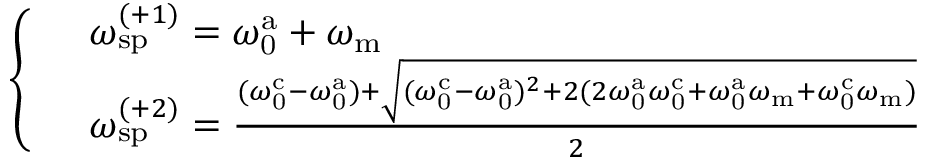Convert formula to latex. <formula><loc_0><loc_0><loc_500><loc_500>\begin{array} { r l } & { \left \{ \begin{array} { l l } & { \omega _ { s p } ^ { ( + 1 ) } = \omega _ { 0 } ^ { a } + \omega _ { m } } \\ & { \omega _ { s p } ^ { ( + 2 ) } = \frac { ( \omega _ { 0 } ^ { c } - \omega _ { 0 } ^ { a } ) + \sqrt { ( \omega _ { 0 } ^ { c } - \omega _ { 0 } ^ { a } ) ^ { 2 } + 2 ( 2 \omega _ { 0 } ^ { a } \omega _ { 0 } ^ { c } + \omega _ { 0 } ^ { a } \omega _ { m } + \omega _ { 0 } ^ { c } \omega _ { m } ) } } { 2 } } \end{array} } \end{array}</formula> 